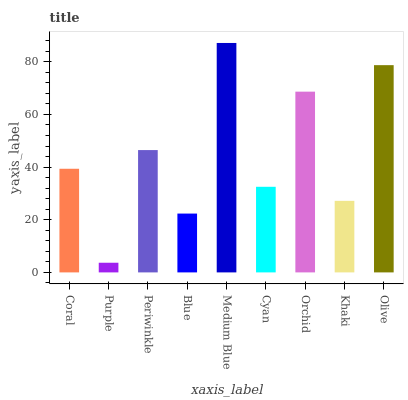Is Purple the minimum?
Answer yes or no. Yes. Is Medium Blue the maximum?
Answer yes or no. Yes. Is Periwinkle the minimum?
Answer yes or no. No. Is Periwinkle the maximum?
Answer yes or no. No. Is Periwinkle greater than Purple?
Answer yes or no. Yes. Is Purple less than Periwinkle?
Answer yes or no. Yes. Is Purple greater than Periwinkle?
Answer yes or no. No. Is Periwinkle less than Purple?
Answer yes or no. No. Is Coral the high median?
Answer yes or no. Yes. Is Coral the low median?
Answer yes or no. Yes. Is Medium Blue the high median?
Answer yes or no. No. Is Orchid the low median?
Answer yes or no. No. 